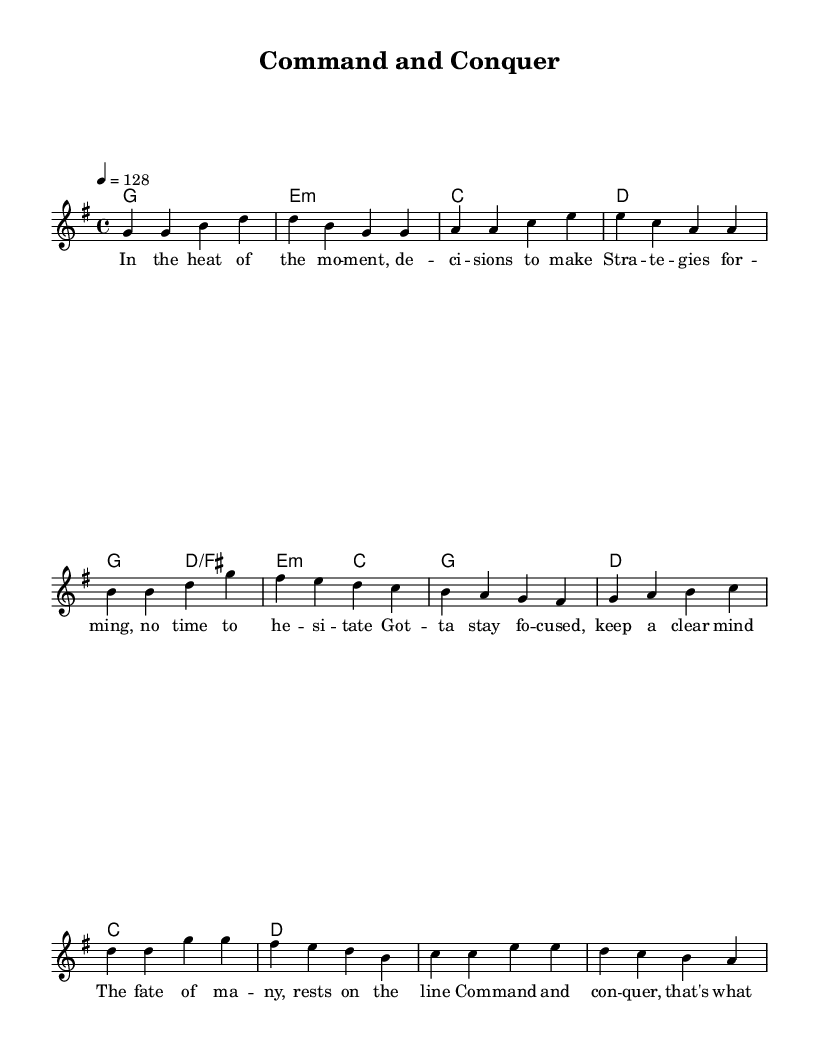What is the key signature of this music? The key signature is G major, which has one sharp (F sharp). This can be identified by looking at the key signature indicated at the beginning of the staff.
Answer: G major What is the time signature of this music? The time signature is 4/4, which can be found at the beginning of the music notation. This means there are four beats in each measure and a quarter note gets one beat.
Answer: 4/4 What is the tempo marking for this piece? The tempo marking indicates a tempo of 128 beats per minute. This is noted at the beginning of the score with the instruction "4 = 128."
Answer: 128 How many measures are in the verse section? The verse consists of 4 measures. This can be counted by analyzing the number of distinct groupings of notes that are separated by vertical bar lines in the verse melody.
Answer: 4 What is the primary theme of the lyrics in the chorus? The primary theme of the chorus centers around leadership and making decisions under pressure. This is evident from the words like "command," "conquer," and "tough choices" that emphasize decisive action and leadership.
Answer: Leadership Which chord is used in the final measure of the chorus? The final measure of the chorus uses the D major chord, as indicated by the chord symbol noted above the melody line. This is important to understand the resolution of the music piece.
Answer: D What type of lyrical content is common in upbeat pop songs like this one? Common lyrical content includes themes of empowerment, motivation, and resilience. This can be inferred from the positive, action-oriented lyrics that convey a sense of urgency and determination typical of upbeat pop music.
Answer: Empowerment 